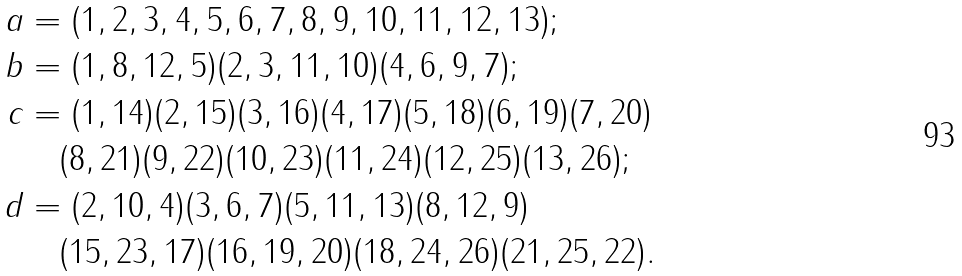<formula> <loc_0><loc_0><loc_500><loc_500>a & = ( 1 , 2 , 3 , 4 , 5 , 6 , 7 , 8 , 9 , 1 0 , 1 1 , 1 2 , 1 3 ) ; \\ b & = ( 1 , 8 , 1 2 , 5 ) ( 2 , 3 , 1 1 , 1 0 ) ( 4 , 6 , 9 , 7 ) ; \\ c & = ( 1 , 1 4 ) ( 2 , 1 5 ) ( 3 , 1 6 ) ( 4 , 1 7 ) ( 5 , 1 8 ) ( 6 , 1 9 ) ( 7 , 2 0 ) \\ & \quad ( 8 , 2 1 ) ( 9 , 2 2 ) ( 1 0 , 2 3 ) ( 1 1 , 2 4 ) ( 1 2 , 2 5 ) ( 1 3 , 2 6 ) ; \\ d & = ( 2 , 1 0 , 4 ) ( 3 , 6 , 7 ) ( 5 , 1 1 , 1 3 ) ( 8 , 1 2 , 9 ) \\ & \quad ( 1 5 , 2 3 , 1 7 ) ( 1 6 , 1 9 , 2 0 ) ( 1 8 , 2 4 , 2 6 ) ( 2 1 , 2 5 , 2 2 ) . \\</formula> 